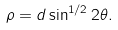Convert formula to latex. <formula><loc_0><loc_0><loc_500><loc_500>\rho = d \sin ^ { 1 / 2 } 2 \theta .</formula> 